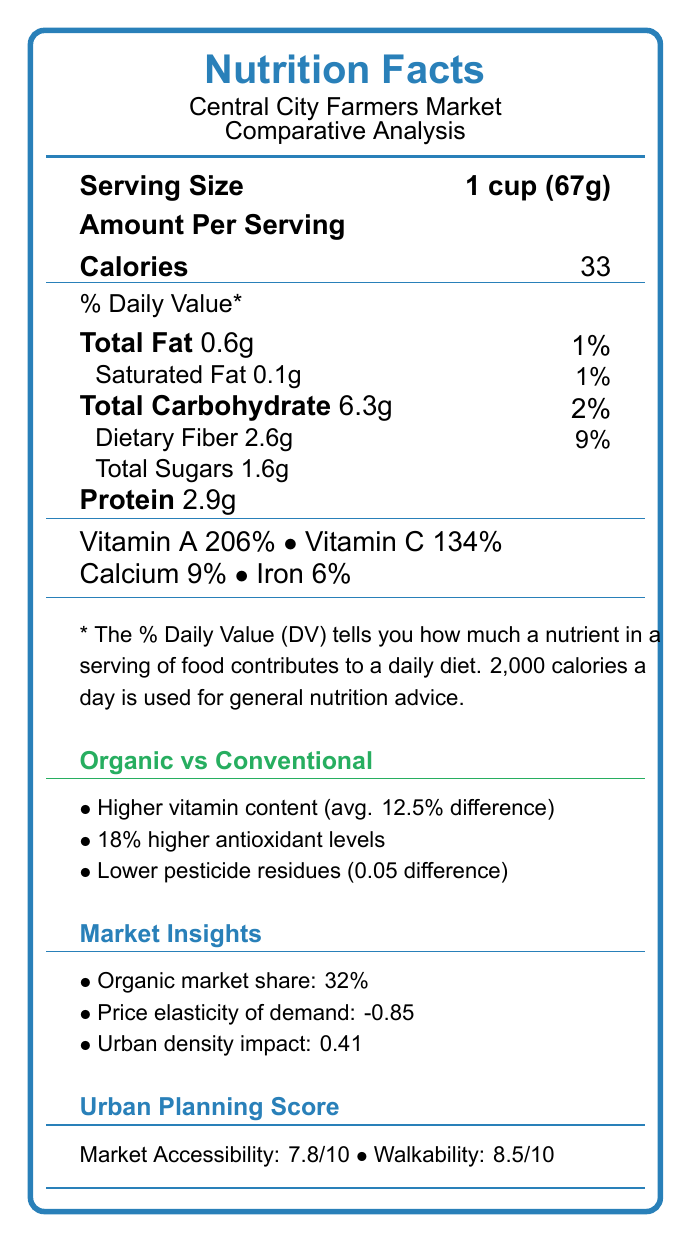What is the serving size of Organic Kale? The document states the serving size for Organic Kale as "1 cup (67g)" under the respective section.
Answer: 1 cup (67g) How many calories are in a serving of Conventional Kale? According to the document, the calorie content per serving of Conventional Kale is listed as 33 calories.
Answer: 33 calories Which has more dietary fiber per serving, Organic or Conventional Kale? The document shows that Organic Kale has 2.6g of dietary fiber, while Conventional Kale has 2.4g.
Answer: Organic Kale What is the vitamin A content for Organic Tomatoes? The nutrition facts for Organic Tomatoes state that Vitamin A is 20% of the DV per serving.
Answer: 20% of the Daily Value (DV) What is the price elasticity of demand according to the document? This value is stated under the section "Market Insights" in the document.
Answer: -0.85 Which of the following is NOT a nutrient listed for both Organic Kale and Conventional Kale?
a. Calcium
b. Vitamin C
c. Potassium
d. Iron Both types of Kale list Calcium, Vitamin C, and Iron, but Potassium is not mentioned.
Answer: c. Potassium Which component shows an 18% higher level in organic produce compared to conventional produce?
a. Fiber
b. Antioxidants
c. Sugar
d. Protein The point about higher antioxidant levels by 18% is clearly stated under "Organic vs Conventional" in the document.
Answer: b. Antioxidants Is the saturated fat content of Organic and Conventional Tomatoes different?
Yes/No Both Organic and Conventional Tomatoes have 0g of saturated fat, as listed in the document.
Answer: No Summarize the main insights provided by the nutrition facts document. The document serves as an in-depth comparative analysis of organic and conventional produce, detailing nutritional content, market behaviors, and urban planning factors influencing accessibility and preferences.
Answer: The document compares the nutrient profiles of organic and conventional produce at the Central City Farmers Market, highlighting the differences in vitamins, antioxidants, and pesticide residues. It also includes market data such as pricing and share, as well as urban planning insights related to market accessibility and consumer preferences. What is the exact seasonal variability factor for market trends? This specific value is given under the "Mathematical Model Variables" section of the document.
Answer: 0.18 How much higher in Vitamin C is Organic Kale compared to Conventional Kale? Organic Kale has 134% Vitamin C, while Conventional Kale has 120%, making it 14% higher.
Answer: 14% Which type of produce, according to the document, has lower levels of pesticide residues? The document specifies that organic produce has lower pesticide residues with a difference of 0.05.
Answer: Organic produce What is Central City Farmers Market's walkability index score? This value is provided under the "Urban Planning Score" section of the document.
Answer: 8.5/10 Can you determine the exact urban density impact from the given document visual? The exact urban density impact value is given as 0.41 in the "Market Insights" section.
Answer: Yes Which category of produce has a greater market share at the Central City Farmers Market? The market share for conventional produce is 68%, whereas organic produce has a 32% market share.
Answer: Conventional produce How do the antioxidant levels compare between organic and conventional produce? This comparison is highlighted in the "Organic vs Conventional" section of the document.
Answer: Organic produce has 18% higher antioxidant levels What factors contribute to the market accessibility score? These factors are detailed under the "Urban Planning Insights" section, affecting the overall market accessibility score.
Answer: Walkability, public transportation proximity What is the neighborhood income correlation in urban planning insights? The "Urban Planning Insights" section highlights a neighborhood income correlation of 0.62.
Answer: 0.62 Is there information provided about the exact number of stalls or vendors at the Farmers Market? The document does not provide any direct information about the number of stalls or vendors.
Answer: No 